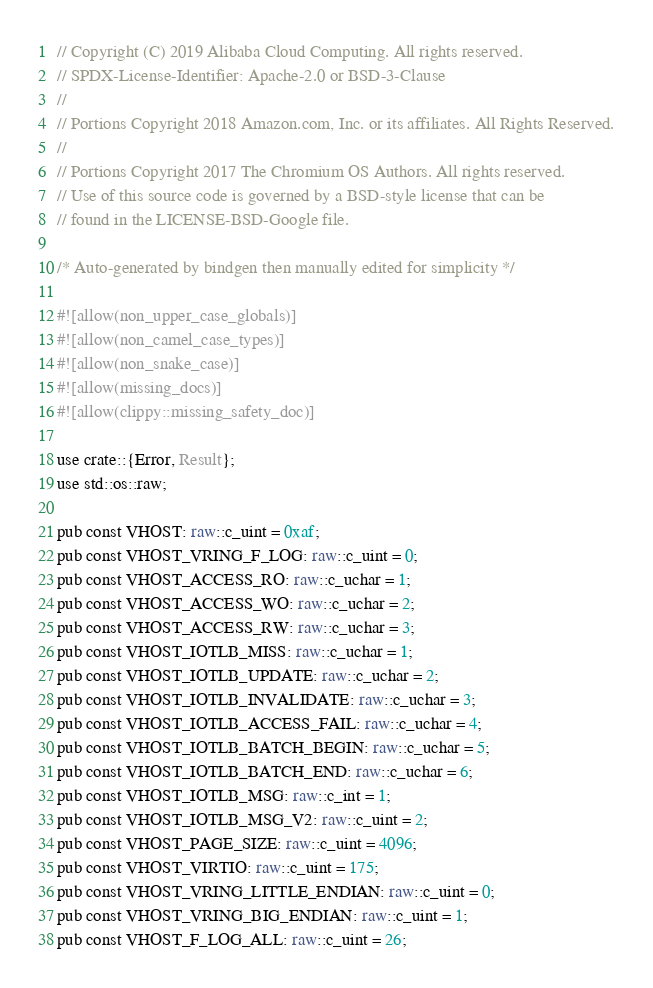<code> <loc_0><loc_0><loc_500><loc_500><_Rust_>// Copyright (C) 2019 Alibaba Cloud Computing. All rights reserved.
// SPDX-License-Identifier: Apache-2.0 or BSD-3-Clause
//
// Portions Copyright 2018 Amazon.com, Inc. or its affiliates. All Rights Reserved.
//
// Portions Copyright 2017 The Chromium OS Authors. All rights reserved.
// Use of this source code is governed by a BSD-style license that can be
// found in the LICENSE-BSD-Google file.

/* Auto-generated by bindgen then manually edited for simplicity */

#![allow(non_upper_case_globals)]
#![allow(non_camel_case_types)]
#![allow(non_snake_case)]
#![allow(missing_docs)]
#![allow(clippy::missing_safety_doc)]

use crate::{Error, Result};
use std::os::raw;

pub const VHOST: raw::c_uint = 0xaf;
pub const VHOST_VRING_F_LOG: raw::c_uint = 0;
pub const VHOST_ACCESS_RO: raw::c_uchar = 1;
pub const VHOST_ACCESS_WO: raw::c_uchar = 2;
pub const VHOST_ACCESS_RW: raw::c_uchar = 3;
pub const VHOST_IOTLB_MISS: raw::c_uchar = 1;
pub const VHOST_IOTLB_UPDATE: raw::c_uchar = 2;
pub const VHOST_IOTLB_INVALIDATE: raw::c_uchar = 3;
pub const VHOST_IOTLB_ACCESS_FAIL: raw::c_uchar = 4;
pub const VHOST_IOTLB_BATCH_BEGIN: raw::c_uchar = 5;
pub const VHOST_IOTLB_BATCH_END: raw::c_uchar = 6;
pub const VHOST_IOTLB_MSG: raw::c_int = 1;
pub const VHOST_IOTLB_MSG_V2: raw::c_uint = 2;
pub const VHOST_PAGE_SIZE: raw::c_uint = 4096;
pub const VHOST_VIRTIO: raw::c_uint = 175;
pub const VHOST_VRING_LITTLE_ENDIAN: raw::c_uint = 0;
pub const VHOST_VRING_BIG_ENDIAN: raw::c_uint = 1;
pub const VHOST_F_LOG_ALL: raw::c_uint = 26;</code> 